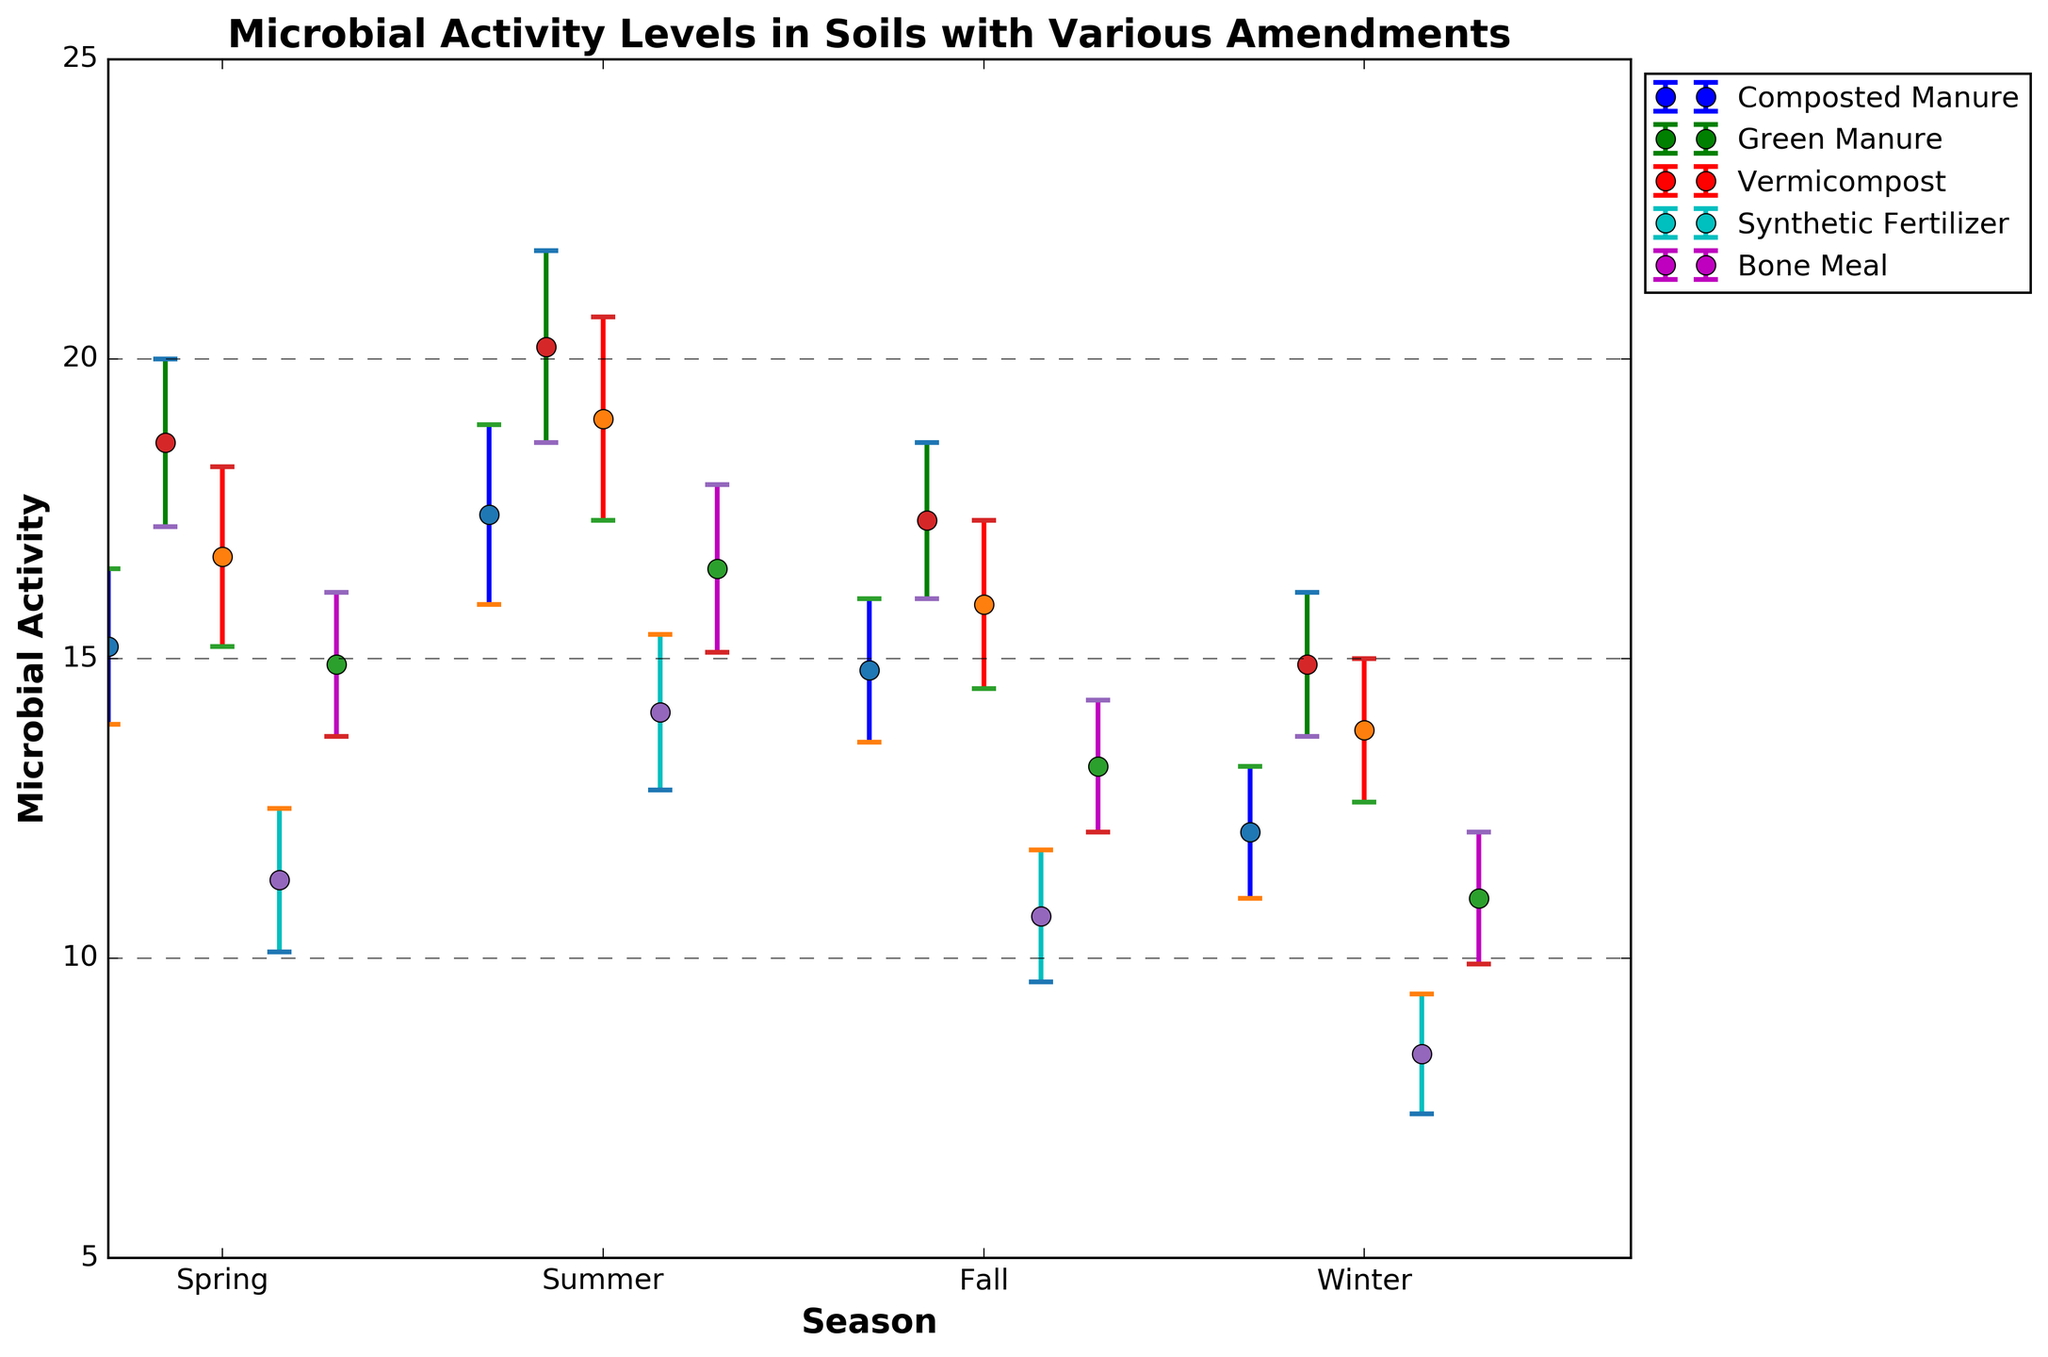What's the title of the figure? The title can be found at the top of the figure, which is typically the most straightforward element to identify.
Answer: Microbial Activity Levels in Soils with Various Amendments What are the labels on the X and Y axes? The X and Y axis labels are explicitly mentioned along the respective axes. 'Season' is on the X-axis and 'Microbial Activity' is on the Y-axis.
Answer: Season; Microbial Activity Which treatment shows the highest microbial activity level in winter? Look at the winter data points and compare the microbial activity levels among the treatments. Green Manure has the highest value.
Answer: Green Manure For Composted Manure, which season shows the lowest microbial activity? Check the data points for Composted Manure across all seasons and identify the smallest value. That value corresponds to Winter.
Answer: Winter How does the microbial activity in Spring compare between Synthetic Fertilizer and Green Manure? Locate the Spring data points for both Synthetic Fertilizer and Green Manure. Green Manure's activity level is much higher than Synthetic Fertilizer's.
Answer: Green Manure is higher What is the difference in microbial activity levels between Green Manure and Bone Meal in Summer? Look at the Summer data points for Green Manure and Bone Meal. Subtract Bone Meal's value (16.5) from Green Manure's value (20.2).
Answer: 3.7 Which treatment consistently has the lowest microbial activity across all seasons? Compare the mean microbial activity levels of each treatment across all seasons and identify the lowest. Synthetic Fertilizer is consistently the lowest.
Answer: Synthetic Fertilizer What's the average microbial activity level of Vermicompost across all four seasons? Sum the mean microbial activity levels of Vermicompost for all seasons and divide by four: (16.7 + 19.0 + 15.9 + 13.8) / 4 = 16.35.
Answer: 16.35 Which treatment has the largest error bar in Summer? Identify the length of the error bars in Summer for all treatments. Vermicompost has the largest error bar as its standard error is 1.7.
Answer: Vermicompost 